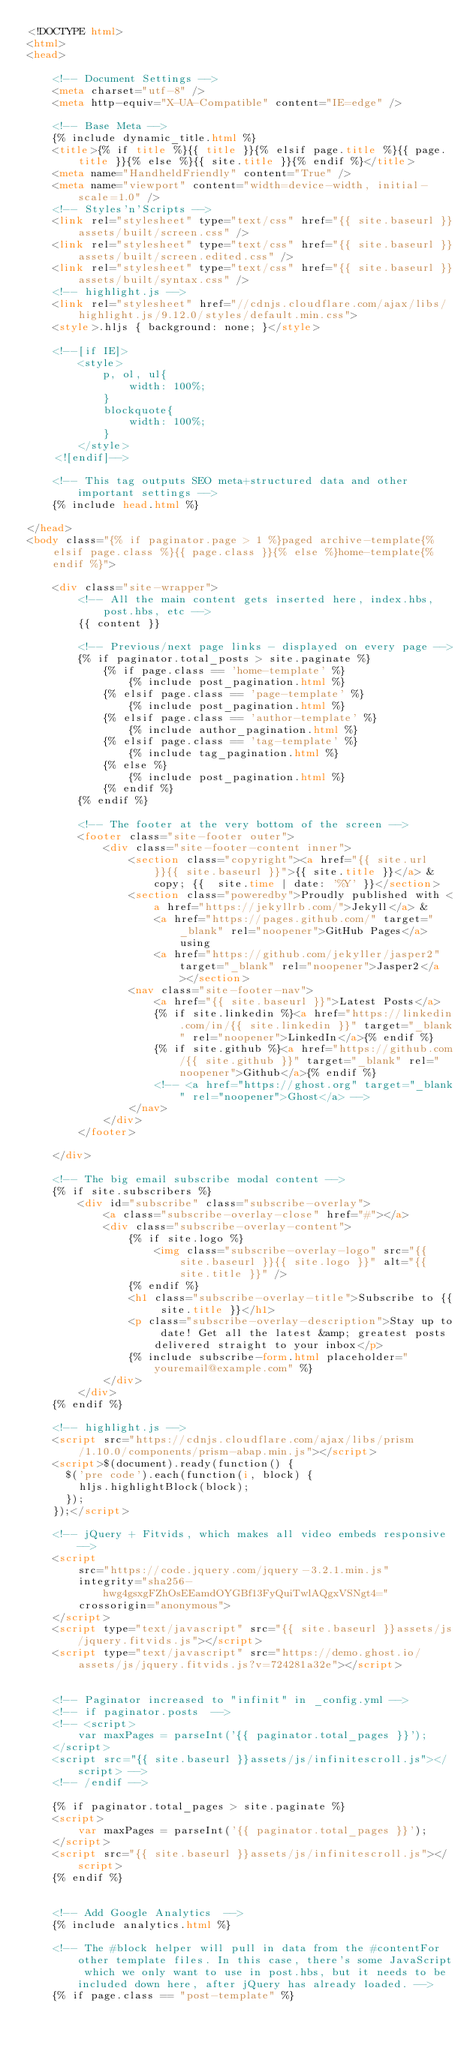<code> <loc_0><loc_0><loc_500><loc_500><_HTML_><!DOCTYPE html>
<html>
<head>

    <!-- Document Settings -->
    <meta charset="utf-8" />
    <meta http-equiv="X-UA-Compatible" content="IE=edge" />

    <!-- Base Meta -->
    {% include dynamic_title.html %}
    <title>{% if title %}{{ title }}{% elsif page.title %}{{ page.title }}{% else %}{{ site.title }}{% endif %}</title>
    <meta name="HandheldFriendly" content="True" />
    <meta name="viewport" content="width=device-width, initial-scale=1.0" />
    <!-- Styles'n'Scripts -->
    <link rel="stylesheet" type="text/css" href="{{ site.baseurl }}assets/built/screen.css" />
    <link rel="stylesheet" type="text/css" href="{{ site.baseurl }}assets/built/screen.edited.css" />
    <link rel="stylesheet" type="text/css" href="{{ site.baseurl }}assets/built/syntax.css" />
    <!-- highlight.js -->
    <link rel="stylesheet" href="//cdnjs.cloudflare.com/ajax/libs/highlight.js/9.12.0/styles/default.min.css">
    <style>.hljs { background: none; }</style>

    <!--[if IE]>
        <style>
            p, ol, ul{
                width: 100%;
            }
            blockquote{
                width: 100%;
            }
        </style>
    <![endif]-->
    
    <!-- This tag outputs SEO meta+structured data and other important settings -->
    {% include head.html %}

</head>
<body class="{% if paginator.page > 1 %}paged archive-template{% elsif page.class %}{{ page.class }}{% else %}home-template{% endif %}">

    <div class="site-wrapper">
        <!-- All the main content gets inserted here, index.hbs, post.hbs, etc -->
        {{ content }}

        <!-- Previous/next page links - displayed on every page -->
        {% if paginator.total_posts > site.paginate %}
            {% if page.class == 'home-template' %}
                {% include post_pagination.html %}
            {% elsif page.class == 'page-template' %}
                {% include post_pagination.html %}
            {% elsif page.class == 'author-template' %}
                {% include author_pagination.html %}
            {% elsif page.class == 'tag-template' %}
                {% include tag_pagination.html %}
            {% else %}
                {% include post_pagination.html %}
            {% endif %}
        {% endif %}

        <!-- The footer at the very bottom of the screen -->
        <footer class="site-footer outer">
            <div class="site-footer-content inner">
                <section class="copyright"><a href="{{ site.url }}{{ site.baseurl }}">{{ site.title }}</a> &copy; {{  site.time | date: '%Y' }}</section>
                <section class="poweredby">Proudly published with <a href="https://jekyllrb.com/">Jekyll</a> &
                    <a href="https://pages.github.com/" target="_blank" rel="noopener">GitHub Pages</a> using
                    <a href="https://github.com/jekyller/jasper2" target="_blank" rel="noopener">Jasper2</a></section>
                <nav class="site-footer-nav">
                    <a href="{{ site.baseurl }}">Latest Posts</a>
                    {% if site.linkedin %}<a href="https://linkedin.com/in/{{ site.linkedin }}" target="_blank" rel="noopener">LinkedIn</a>{% endif %}
                    {% if site.github %}<a href="https://github.com/{{ site.github }}" target="_blank" rel="noopener">Github</a>{% endif %}
                    <!-- <a href="https://ghost.org" target="_blank" rel="noopener">Ghost</a> -->
                </nav>
            </div>
        </footer>

    </div>

    <!-- The big email subscribe modal content -->
    {% if site.subscribers %}
        <div id="subscribe" class="subscribe-overlay">
            <a class="subscribe-overlay-close" href="#"></a>
            <div class="subscribe-overlay-content">
                {% if site.logo %}
                    <img class="subscribe-overlay-logo" src="{{ site.baseurl }}{{ site.logo }}" alt="{{ site.title }}" />
                {% endif %}
                <h1 class="subscribe-overlay-title">Subscribe to {{ site.title }}</h1>
                <p class="subscribe-overlay-description">Stay up to date! Get all the latest &amp; greatest posts delivered straight to your inbox</p>
                {% include subscribe-form.html placeholder="youremail@example.com" %}
            </div>
        </div>
    {% endif %}

    <!-- highlight.js -->
    <script src="https://cdnjs.cloudflare.com/ajax/libs/prism/1.10.0/components/prism-abap.min.js"></script>
    <script>$(document).ready(function() {
      $('pre code').each(function(i, block) {
        hljs.highlightBlock(block);
      });
    });</script>

    <!-- jQuery + Fitvids, which makes all video embeds responsive -->
    <script
        src="https://code.jquery.com/jquery-3.2.1.min.js"
        integrity="sha256-hwg4gsxgFZhOsEEamdOYGBf13FyQuiTwlAQgxVSNgt4="
        crossorigin="anonymous">
    </script>
    <script type="text/javascript" src="{{ site.baseurl }}assets/js/jquery.fitvids.js"></script>
    <script type="text/javascript" src="https://demo.ghost.io/assets/js/jquery.fitvids.js?v=724281a32e"></script>


    <!-- Paginator increased to "infinit" in _config.yml -->
    <!-- if paginator.posts  -->
    <!-- <script>
        var maxPages = parseInt('{{ paginator.total_pages }}');
    </script>
    <script src="{{ site.baseurl }}assets/js/infinitescroll.js"></script> -->
    <!-- /endif -->

    {% if paginator.total_pages > site.paginate %}
    <script>
        var maxPages = parseInt('{{ paginator.total_pages }}');
    </script>
    <script src="{{ site.baseurl }}assets/js/infinitescroll.js"></script>
    {% endif %}


    <!-- Add Google Analytics  -->
    {% include analytics.html %}

    <!-- The #block helper will pull in data from the #contentFor other template files. In this case, there's some JavaScript which we only want to use in post.hbs, but it needs to be included down here, after jQuery has already loaded. -->
    {% if page.class == "post-template" %}</code> 